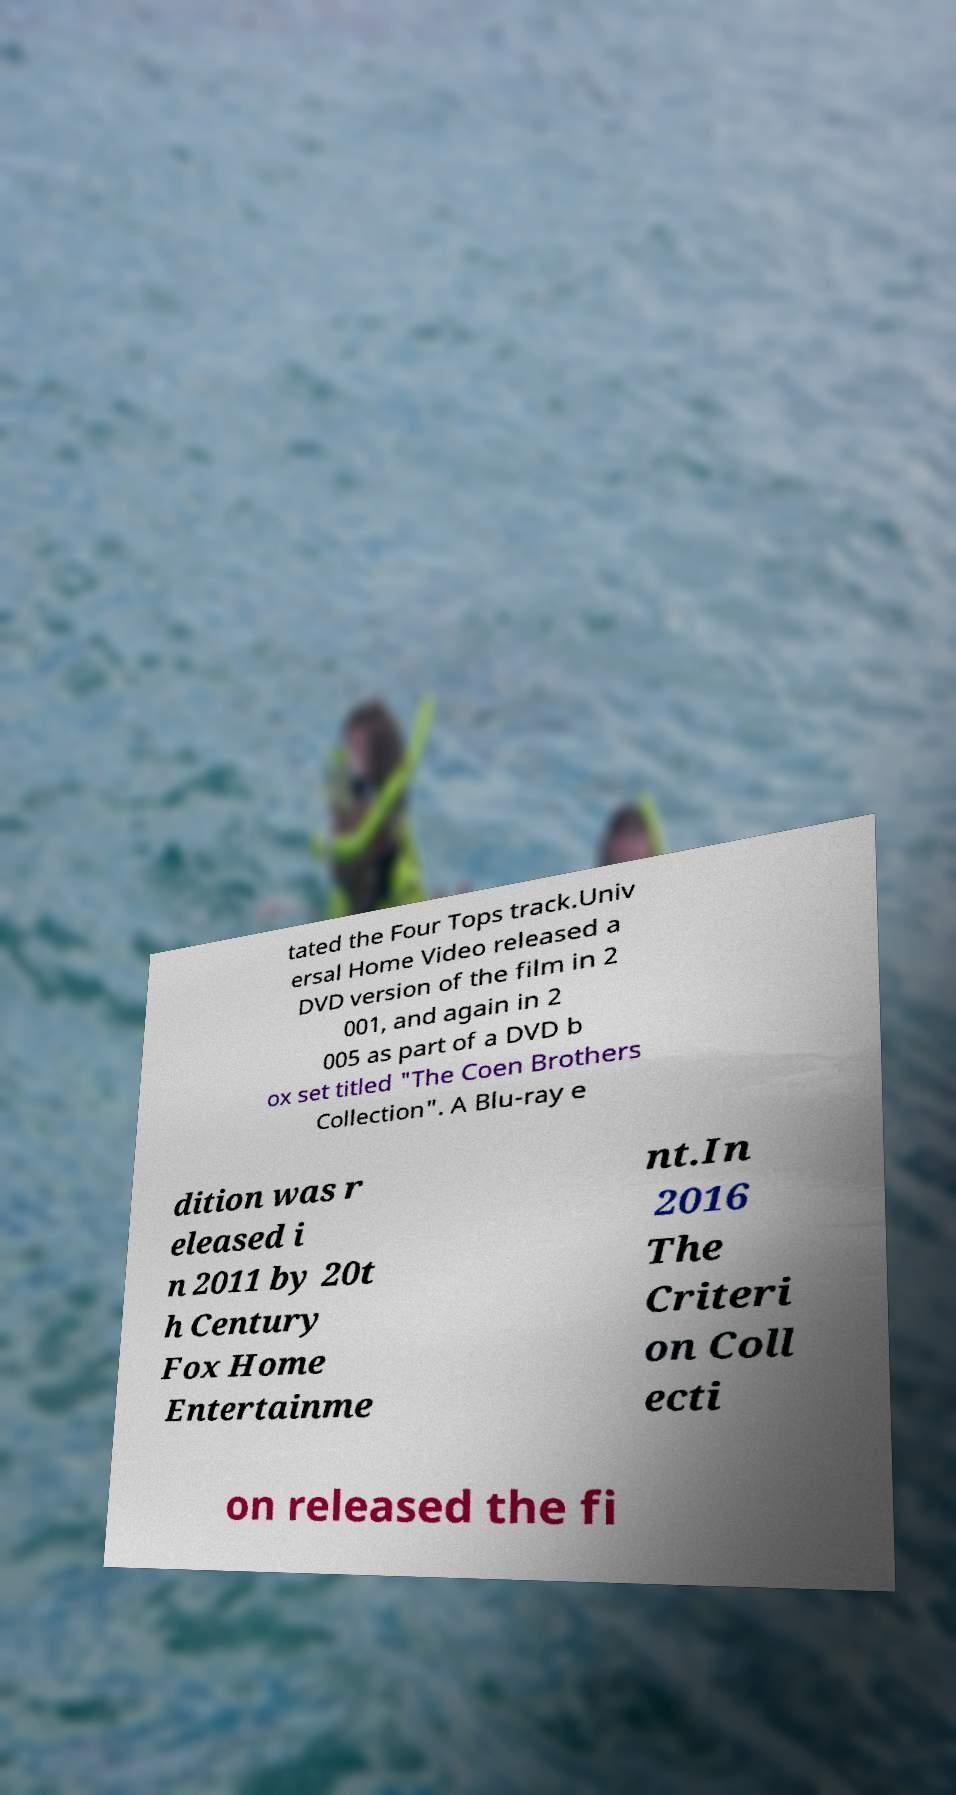Can you accurately transcribe the text from the provided image for me? tated the Four Tops track.Univ ersal Home Video released a DVD version of the film in 2 001, and again in 2 005 as part of a DVD b ox set titled "The Coen Brothers Collection". A Blu-ray e dition was r eleased i n 2011 by 20t h Century Fox Home Entertainme nt.In 2016 The Criteri on Coll ecti on released the fi 